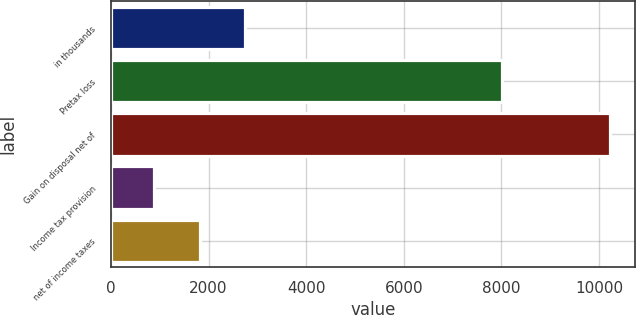Convert chart. <chart><loc_0><loc_0><loc_500><loc_500><bar_chart><fcel>in thousands<fcel>Pretax loss<fcel>Gain on disposal net of<fcel>Income tax provision<fcel>net of income taxes<nl><fcel>2752<fcel>8017<fcel>10232<fcel>882<fcel>1817<nl></chart> 